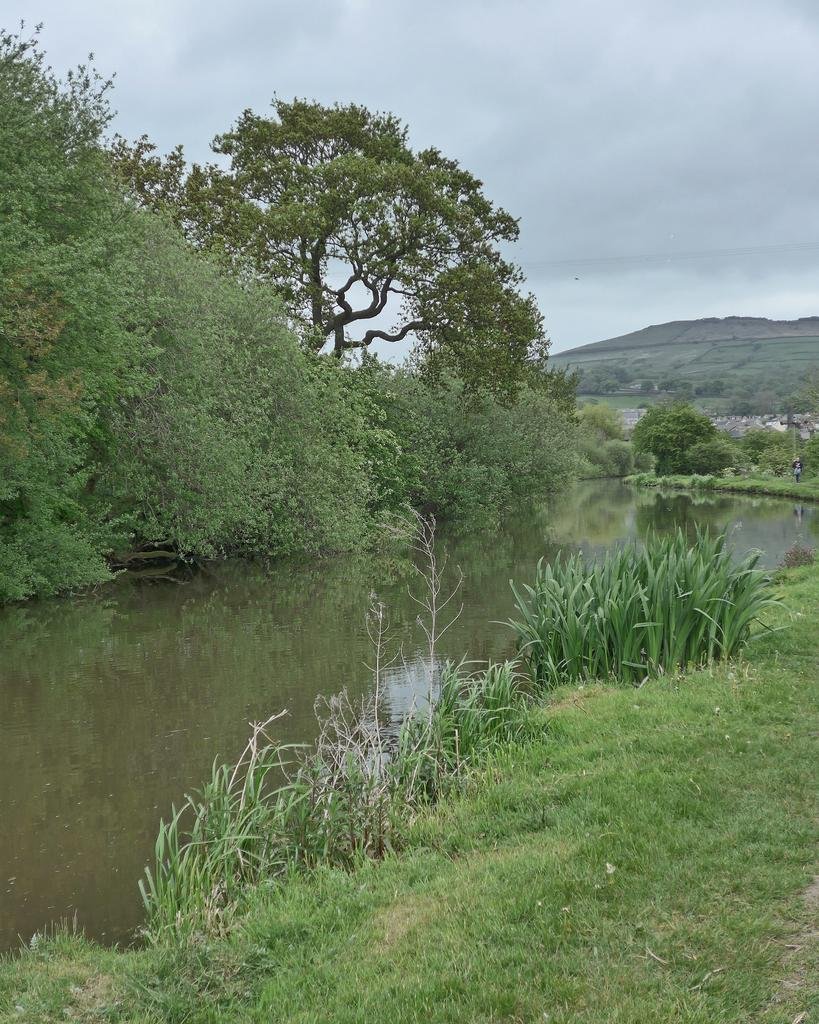What is one of the main elements in the picture? There is water in the picture. What type of vegetation can be seen in the picture? There are trees, plants, and grass in the picture. What can be seen in the background of the picture? The sky is visible in the background of the picture. What type of humor can be seen in the picture? There is no humor present in the image; it is a picture of natural elements such as water, trees, plants, grass, and the sky. 